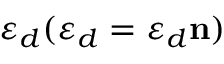Convert formula to latex. <formula><loc_0><loc_0><loc_500><loc_500>\varepsilon _ { d } ( \varepsilon _ { d } = \varepsilon _ { d } n )</formula> 